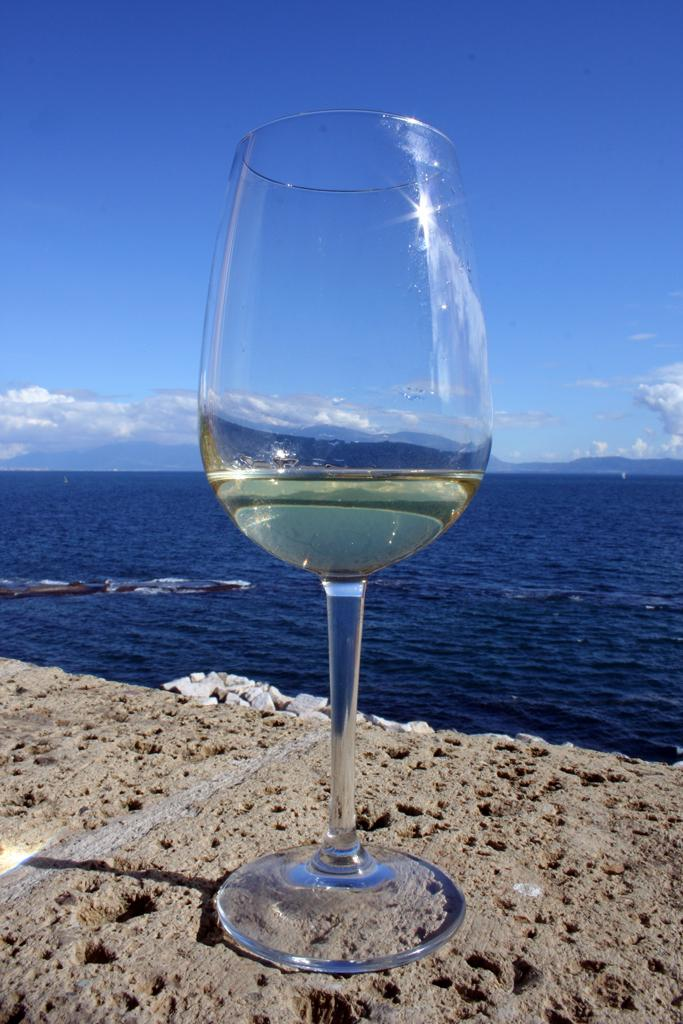What is in the glass that is visible in the image? There is a glass with liquid in the image. What can be seen in the background of the image? There are stones, water, hills, and the sky visible in the background of the image. What type of stamp can be seen on the glass in the image? There is no stamp present on the glass in the image. What color is the person's hair in the image? There are no people visible in the image, so we cannot determine the color of anyone's hair. 